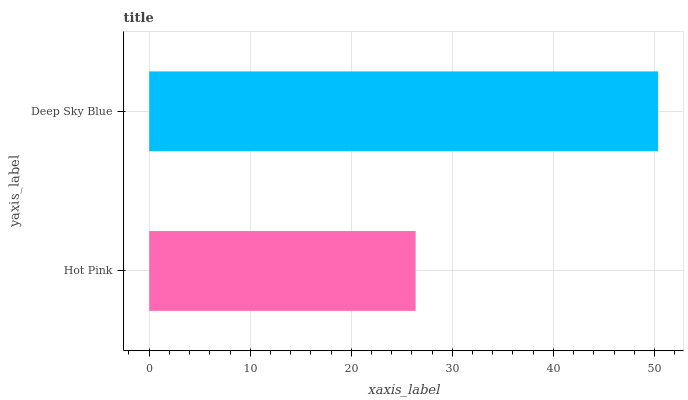Is Hot Pink the minimum?
Answer yes or no. Yes. Is Deep Sky Blue the maximum?
Answer yes or no. Yes. Is Deep Sky Blue the minimum?
Answer yes or no. No. Is Deep Sky Blue greater than Hot Pink?
Answer yes or no. Yes. Is Hot Pink less than Deep Sky Blue?
Answer yes or no. Yes. Is Hot Pink greater than Deep Sky Blue?
Answer yes or no. No. Is Deep Sky Blue less than Hot Pink?
Answer yes or no. No. Is Deep Sky Blue the high median?
Answer yes or no. Yes. Is Hot Pink the low median?
Answer yes or no. Yes. Is Hot Pink the high median?
Answer yes or no. No. Is Deep Sky Blue the low median?
Answer yes or no. No. 